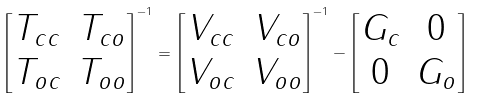<formula> <loc_0><loc_0><loc_500><loc_500>\begin{bmatrix} T _ { c c } & T _ { c o } \\ T _ { o c } & T _ { o o } \end{bmatrix} ^ { - 1 } = \begin{bmatrix} V _ { c c } & V _ { c o } \\ V _ { o c } & V _ { o o } \end{bmatrix} ^ { - 1 } - \begin{bmatrix} G _ { c } & 0 \\ 0 & G _ { o } \end{bmatrix}</formula> 